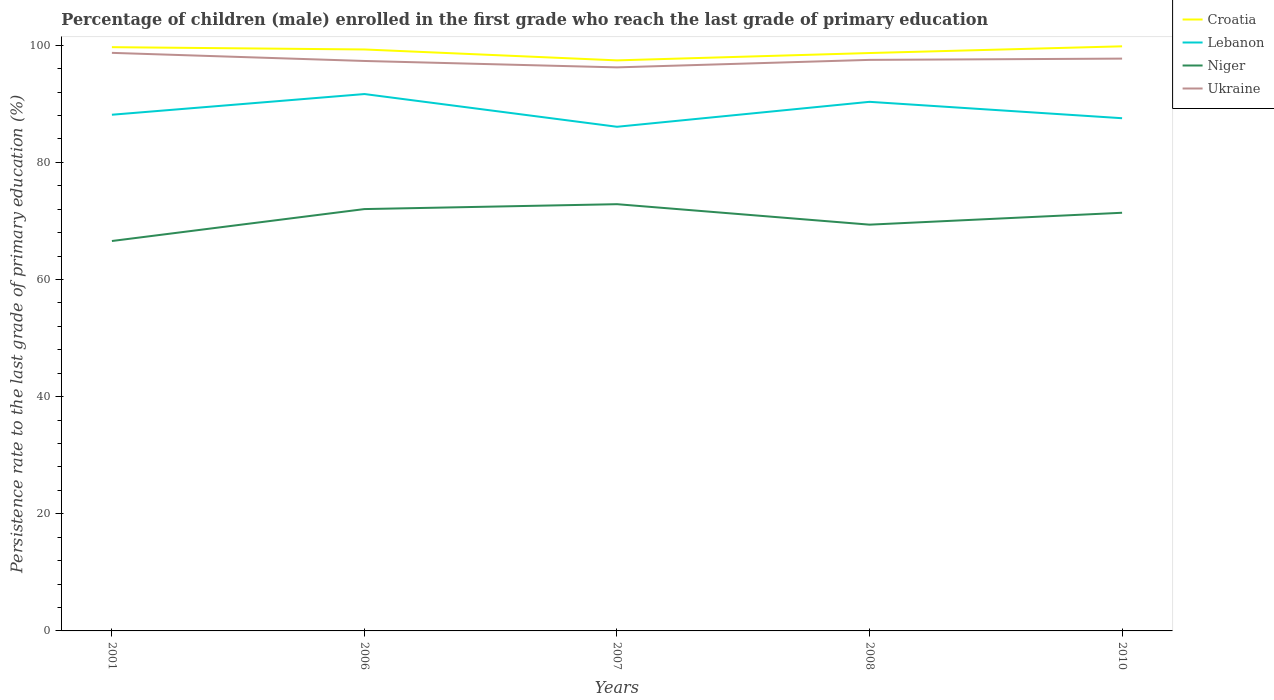How many different coloured lines are there?
Keep it short and to the point. 4. Does the line corresponding to Lebanon intersect with the line corresponding to Niger?
Ensure brevity in your answer.  No. Is the number of lines equal to the number of legend labels?
Ensure brevity in your answer.  Yes. Across all years, what is the maximum persistence rate of children in Lebanon?
Offer a terse response. 86.07. In which year was the persistence rate of children in Ukraine maximum?
Provide a succinct answer. 2007. What is the total persistence rate of children in Niger in the graph?
Your response must be concise. -4.82. What is the difference between the highest and the second highest persistence rate of children in Niger?
Make the answer very short. 6.29. How many lines are there?
Make the answer very short. 4. Does the graph contain any zero values?
Ensure brevity in your answer.  No. Does the graph contain grids?
Your answer should be very brief. No. How many legend labels are there?
Give a very brief answer. 4. What is the title of the graph?
Give a very brief answer. Percentage of children (male) enrolled in the first grade who reach the last grade of primary education. Does "Mauritania" appear as one of the legend labels in the graph?
Keep it short and to the point. No. What is the label or title of the X-axis?
Keep it short and to the point. Years. What is the label or title of the Y-axis?
Offer a terse response. Persistence rate to the last grade of primary education (%). What is the Persistence rate to the last grade of primary education (%) in Croatia in 2001?
Offer a very short reply. 99.66. What is the Persistence rate to the last grade of primary education (%) of Lebanon in 2001?
Keep it short and to the point. 88.13. What is the Persistence rate to the last grade of primary education (%) in Niger in 2001?
Your answer should be compact. 66.57. What is the Persistence rate to the last grade of primary education (%) of Ukraine in 2001?
Your answer should be compact. 98.69. What is the Persistence rate to the last grade of primary education (%) of Croatia in 2006?
Provide a succinct answer. 99.27. What is the Persistence rate to the last grade of primary education (%) of Lebanon in 2006?
Provide a succinct answer. 91.66. What is the Persistence rate to the last grade of primary education (%) in Niger in 2006?
Your answer should be compact. 72.02. What is the Persistence rate to the last grade of primary education (%) of Ukraine in 2006?
Ensure brevity in your answer.  97.31. What is the Persistence rate to the last grade of primary education (%) in Croatia in 2007?
Ensure brevity in your answer.  97.41. What is the Persistence rate to the last grade of primary education (%) in Lebanon in 2007?
Give a very brief answer. 86.07. What is the Persistence rate to the last grade of primary education (%) of Niger in 2007?
Keep it short and to the point. 72.86. What is the Persistence rate to the last grade of primary education (%) in Ukraine in 2007?
Make the answer very short. 96.22. What is the Persistence rate to the last grade of primary education (%) in Croatia in 2008?
Your response must be concise. 98.66. What is the Persistence rate to the last grade of primary education (%) of Lebanon in 2008?
Give a very brief answer. 90.33. What is the Persistence rate to the last grade of primary education (%) of Niger in 2008?
Your response must be concise. 69.36. What is the Persistence rate to the last grade of primary education (%) of Ukraine in 2008?
Provide a short and direct response. 97.5. What is the Persistence rate to the last grade of primary education (%) in Croatia in 2010?
Your answer should be compact. 99.81. What is the Persistence rate to the last grade of primary education (%) of Lebanon in 2010?
Make the answer very short. 87.54. What is the Persistence rate to the last grade of primary education (%) in Niger in 2010?
Keep it short and to the point. 71.39. What is the Persistence rate to the last grade of primary education (%) in Ukraine in 2010?
Keep it short and to the point. 97.71. Across all years, what is the maximum Persistence rate to the last grade of primary education (%) in Croatia?
Make the answer very short. 99.81. Across all years, what is the maximum Persistence rate to the last grade of primary education (%) in Lebanon?
Ensure brevity in your answer.  91.66. Across all years, what is the maximum Persistence rate to the last grade of primary education (%) of Niger?
Ensure brevity in your answer.  72.86. Across all years, what is the maximum Persistence rate to the last grade of primary education (%) of Ukraine?
Provide a short and direct response. 98.69. Across all years, what is the minimum Persistence rate to the last grade of primary education (%) in Croatia?
Offer a very short reply. 97.41. Across all years, what is the minimum Persistence rate to the last grade of primary education (%) in Lebanon?
Your response must be concise. 86.07. Across all years, what is the minimum Persistence rate to the last grade of primary education (%) of Niger?
Your response must be concise. 66.57. Across all years, what is the minimum Persistence rate to the last grade of primary education (%) in Ukraine?
Offer a very short reply. 96.22. What is the total Persistence rate to the last grade of primary education (%) in Croatia in the graph?
Offer a terse response. 494.82. What is the total Persistence rate to the last grade of primary education (%) in Lebanon in the graph?
Offer a terse response. 443.74. What is the total Persistence rate to the last grade of primary education (%) in Niger in the graph?
Offer a terse response. 352.21. What is the total Persistence rate to the last grade of primary education (%) in Ukraine in the graph?
Give a very brief answer. 487.43. What is the difference between the Persistence rate to the last grade of primary education (%) in Croatia in 2001 and that in 2006?
Provide a short and direct response. 0.39. What is the difference between the Persistence rate to the last grade of primary education (%) of Lebanon in 2001 and that in 2006?
Give a very brief answer. -3.53. What is the difference between the Persistence rate to the last grade of primary education (%) of Niger in 2001 and that in 2006?
Your answer should be very brief. -5.45. What is the difference between the Persistence rate to the last grade of primary education (%) of Ukraine in 2001 and that in 2006?
Your answer should be very brief. 1.39. What is the difference between the Persistence rate to the last grade of primary education (%) of Croatia in 2001 and that in 2007?
Keep it short and to the point. 2.25. What is the difference between the Persistence rate to the last grade of primary education (%) of Lebanon in 2001 and that in 2007?
Give a very brief answer. 2.06. What is the difference between the Persistence rate to the last grade of primary education (%) of Niger in 2001 and that in 2007?
Give a very brief answer. -6.29. What is the difference between the Persistence rate to the last grade of primary education (%) in Ukraine in 2001 and that in 2007?
Make the answer very short. 2.48. What is the difference between the Persistence rate to the last grade of primary education (%) of Lebanon in 2001 and that in 2008?
Your answer should be very brief. -2.2. What is the difference between the Persistence rate to the last grade of primary education (%) in Niger in 2001 and that in 2008?
Make the answer very short. -2.79. What is the difference between the Persistence rate to the last grade of primary education (%) of Ukraine in 2001 and that in 2008?
Offer a terse response. 1.2. What is the difference between the Persistence rate to the last grade of primary education (%) in Croatia in 2001 and that in 2010?
Provide a succinct answer. -0.15. What is the difference between the Persistence rate to the last grade of primary education (%) in Lebanon in 2001 and that in 2010?
Make the answer very short. 0.59. What is the difference between the Persistence rate to the last grade of primary education (%) of Niger in 2001 and that in 2010?
Make the answer very short. -4.82. What is the difference between the Persistence rate to the last grade of primary education (%) in Ukraine in 2001 and that in 2010?
Offer a terse response. 0.98. What is the difference between the Persistence rate to the last grade of primary education (%) of Croatia in 2006 and that in 2007?
Ensure brevity in your answer.  1.86. What is the difference between the Persistence rate to the last grade of primary education (%) in Lebanon in 2006 and that in 2007?
Ensure brevity in your answer.  5.59. What is the difference between the Persistence rate to the last grade of primary education (%) of Niger in 2006 and that in 2007?
Your answer should be very brief. -0.84. What is the difference between the Persistence rate to the last grade of primary education (%) of Ukraine in 2006 and that in 2007?
Give a very brief answer. 1.09. What is the difference between the Persistence rate to the last grade of primary education (%) in Croatia in 2006 and that in 2008?
Ensure brevity in your answer.  0.61. What is the difference between the Persistence rate to the last grade of primary education (%) of Lebanon in 2006 and that in 2008?
Your response must be concise. 1.33. What is the difference between the Persistence rate to the last grade of primary education (%) in Niger in 2006 and that in 2008?
Give a very brief answer. 2.66. What is the difference between the Persistence rate to the last grade of primary education (%) of Ukraine in 2006 and that in 2008?
Keep it short and to the point. -0.19. What is the difference between the Persistence rate to the last grade of primary education (%) in Croatia in 2006 and that in 2010?
Ensure brevity in your answer.  -0.54. What is the difference between the Persistence rate to the last grade of primary education (%) in Lebanon in 2006 and that in 2010?
Give a very brief answer. 4.13. What is the difference between the Persistence rate to the last grade of primary education (%) of Niger in 2006 and that in 2010?
Offer a very short reply. 0.63. What is the difference between the Persistence rate to the last grade of primary education (%) of Ukraine in 2006 and that in 2010?
Give a very brief answer. -0.4. What is the difference between the Persistence rate to the last grade of primary education (%) of Croatia in 2007 and that in 2008?
Offer a very short reply. -1.25. What is the difference between the Persistence rate to the last grade of primary education (%) in Lebanon in 2007 and that in 2008?
Keep it short and to the point. -4.26. What is the difference between the Persistence rate to the last grade of primary education (%) of Niger in 2007 and that in 2008?
Offer a terse response. 3.5. What is the difference between the Persistence rate to the last grade of primary education (%) of Ukraine in 2007 and that in 2008?
Ensure brevity in your answer.  -1.28. What is the difference between the Persistence rate to the last grade of primary education (%) of Croatia in 2007 and that in 2010?
Provide a succinct answer. -2.4. What is the difference between the Persistence rate to the last grade of primary education (%) in Lebanon in 2007 and that in 2010?
Your response must be concise. -1.46. What is the difference between the Persistence rate to the last grade of primary education (%) of Niger in 2007 and that in 2010?
Make the answer very short. 1.46. What is the difference between the Persistence rate to the last grade of primary education (%) of Ukraine in 2007 and that in 2010?
Your answer should be compact. -1.5. What is the difference between the Persistence rate to the last grade of primary education (%) in Croatia in 2008 and that in 2010?
Keep it short and to the point. -1.15. What is the difference between the Persistence rate to the last grade of primary education (%) of Lebanon in 2008 and that in 2010?
Ensure brevity in your answer.  2.8. What is the difference between the Persistence rate to the last grade of primary education (%) of Niger in 2008 and that in 2010?
Provide a short and direct response. -2.03. What is the difference between the Persistence rate to the last grade of primary education (%) of Ukraine in 2008 and that in 2010?
Provide a short and direct response. -0.22. What is the difference between the Persistence rate to the last grade of primary education (%) of Croatia in 2001 and the Persistence rate to the last grade of primary education (%) of Lebanon in 2006?
Your answer should be very brief. 8. What is the difference between the Persistence rate to the last grade of primary education (%) in Croatia in 2001 and the Persistence rate to the last grade of primary education (%) in Niger in 2006?
Your response must be concise. 27.64. What is the difference between the Persistence rate to the last grade of primary education (%) in Croatia in 2001 and the Persistence rate to the last grade of primary education (%) in Ukraine in 2006?
Your answer should be compact. 2.36. What is the difference between the Persistence rate to the last grade of primary education (%) of Lebanon in 2001 and the Persistence rate to the last grade of primary education (%) of Niger in 2006?
Give a very brief answer. 16.11. What is the difference between the Persistence rate to the last grade of primary education (%) of Lebanon in 2001 and the Persistence rate to the last grade of primary education (%) of Ukraine in 2006?
Ensure brevity in your answer.  -9.18. What is the difference between the Persistence rate to the last grade of primary education (%) in Niger in 2001 and the Persistence rate to the last grade of primary education (%) in Ukraine in 2006?
Give a very brief answer. -30.74. What is the difference between the Persistence rate to the last grade of primary education (%) of Croatia in 2001 and the Persistence rate to the last grade of primary education (%) of Lebanon in 2007?
Offer a terse response. 13.59. What is the difference between the Persistence rate to the last grade of primary education (%) of Croatia in 2001 and the Persistence rate to the last grade of primary education (%) of Niger in 2007?
Offer a very short reply. 26.81. What is the difference between the Persistence rate to the last grade of primary education (%) of Croatia in 2001 and the Persistence rate to the last grade of primary education (%) of Ukraine in 2007?
Provide a short and direct response. 3.45. What is the difference between the Persistence rate to the last grade of primary education (%) in Lebanon in 2001 and the Persistence rate to the last grade of primary education (%) in Niger in 2007?
Make the answer very short. 15.27. What is the difference between the Persistence rate to the last grade of primary education (%) of Lebanon in 2001 and the Persistence rate to the last grade of primary education (%) of Ukraine in 2007?
Provide a succinct answer. -8.09. What is the difference between the Persistence rate to the last grade of primary education (%) of Niger in 2001 and the Persistence rate to the last grade of primary education (%) of Ukraine in 2007?
Ensure brevity in your answer.  -29.65. What is the difference between the Persistence rate to the last grade of primary education (%) of Croatia in 2001 and the Persistence rate to the last grade of primary education (%) of Lebanon in 2008?
Offer a terse response. 9.33. What is the difference between the Persistence rate to the last grade of primary education (%) in Croatia in 2001 and the Persistence rate to the last grade of primary education (%) in Niger in 2008?
Give a very brief answer. 30.3. What is the difference between the Persistence rate to the last grade of primary education (%) in Croatia in 2001 and the Persistence rate to the last grade of primary education (%) in Ukraine in 2008?
Provide a short and direct response. 2.17. What is the difference between the Persistence rate to the last grade of primary education (%) in Lebanon in 2001 and the Persistence rate to the last grade of primary education (%) in Niger in 2008?
Your response must be concise. 18.77. What is the difference between the Persistence rate to the last grade of primary education (%) in Lebanon in 2001 and the Persistence rate to the last grade of primary education (%) in Ukraine in 2008?
Your answer should be compact. -9.37. What is the difference between the Persistence rate to the last grade of primary education (%) of Niger in 2001 and the Persistence rate to the last grade of primary education (%) of Ukraine in 2008?
Provide a succinct answer. -30.92. What is the difference between the Persistence rate to the last grade of primary education (%) in Croatia in 2001 and the Persistence rate to the last grade of primary education (%) in Lebanon in 2010?
Keep it short and to the point. 12.13. What is the difference between the Persistence rate to the last grade of primary education (%) of Croatia in 2001 and the Persistence rate to the last grade of primary education (%) of Niger in 2010?
Your response must be concise. 28.27. What is the difference between the Persistence rate to the last grade of primary education (%) of Croatia in 2001 and the Persistence rate to the last grade of primary education (%) of Ukraine in 2010?
Offer a terse response. 1.95. What is the difference between the Persistence rate to the last grade of primary education (%) of Lebanon in 2001 and the Persistence rate to the last grade of primary education (%) of Niger in 2010?
Your answer should be very brief. 16.74. What is the difference between the Persistence rate to the last grade of primary education (%) in Lebanon in 2001 and the Persistence rate to the last grade of primary education (%) in Ukraine in 2010?
Provide a short and direct response. -9.58. What is the difference between the Persistence rate to the last grade of primary education (%) of Niger in 2001 and the Persistence rate to the last grade of primary education (%) of Ukraine in 2010?
Provide a succinct answer. -31.14. What is the difference between the Persistence rate to the last grade of primary education (%) in Croatia in 2006 and the Persistence rate to the last grade of primary education (%) in Lebanon in 2007?
Your response must be concise. 13.2. What is the difference between the Persistence rate to the last grade of primary education (%) in Croatia in 2006 and the Persistence rate to the last grade of primary education (%) in Niger in 2007?
Offer a very short reply. 26.41. What is the difference between the Persistence rate to the last grade of primary education (%) in Croatia in 2006 and the Persistence rate to the last grade of primary education (%) in Ukraine in 2007?
Keep it short and to the point. 3.06. What is the difference between the Persistence rate to the last grade of primary education (%) in Lebanon in 2006 and the Persistence rate to the last grade of primary education (%) in Niger in 2007?
Give a very brief answer. 18.8. What is the difference between the Persistence rate to the last grade of primary education (%) of Lebanon in 2006 and the Persistence rate to the last grade of primary education (%) of Ukraine in 2007?
Give a very brief answer. -4.55. What is the difference between the Persistence rate to the last grade of primary education (%) in Niger in 2006 and the Persistence rate to the last grade of primary education (%) in Ukraine in 2007?
Provide a short and direct response. -24.19. What is the difference between the Persistence rate to the last grade of primary education (%) in Croatia in 2006 and the Persistence rate to the last grade of primary education (%) in Lebanon in 2008?
Ensure brevity in your answer.  8.94. What is the difference between the Persistence rate to the last grade of primary education (%) of Croatia in 2006 and the Persistence rate to the last grade of primary education (%) of Niger in 2008?
Provide a succinct answer. 29.91. What is the difference between the Persistence rate to the last grade of primary education (%) of Croatia in 2006 and the Persistence rate to the last grade of primary education (%) of Ukraine in 2008?
Your answer should be very brief. 1.78. What is the difference between the Persistence rate to the last grade of primary education (%) of Lebanon in 2006 and the Persistence rate to the last grade of primary education (%) of Niger in 2008?
Keep it short and to the point. 22.3. What is the difference between the Persistence rate to the last grade of primary education (%) in Lebanon in 2006 and the Persistence rate to the last grade of primary education (%) in Ukraine in 2008?
Offer a very short reply. -5.83. What is the difference between the Persistence rate to the last grade of primary education (%) of Niger in 2006 and the Persistence rate to the last grade of primary education (%) of Ukraine in 2008?
Your answer should be compact. -25.47. What is the difference between the Persistence rate to the last grade of primary education (%) of Croatia in 2006 and the Persistence rate to the last grade of primary education (%) of Lebanon in 2010?
Make the answer very short. 11.74. What is the difference between the Persistence rate to the last grade of primary education (%) of Croatia in 2006 and the Persistence rate to the last grade of primary education (%) of Niger in 2010?
Offer a terse response. 27.88. What is the difference between the Persistence rate to the last grade of primary education (%) of Croatia in 2006 and the Persistence rate to the last grade of primary education (%) of Ukraine in 2010?
Your response must be concise. 1.56. What is the difference between the Persistence rate to the last grade of primary education (%) of Lebanon in 2006 and the Persistence rate to the last grade of primary education (%) of Niger in 2010?
Your response must be concise. 20.27. What is the difference between the Persistence rate to the last grade of primary education (%) in Lebanon in 2006 and the Persistence rate to the last grade of primary education (%) in Ukraine in 2010?
Provide a succinct answer. -6.05. What is the difference between the Persistence rate to the last grade of primary education (%) in Niger in 2006 and the Persistence rate to the last grade of primary education (%) in Ukraine in 2010?
Offer a very short reply. -25.69. What is the difference between the Persistence rate to the last grade of primary education (%) of Croatia in 2007 and the Persistence rate to the last grade of primary education (%) of Lebanon in 2008?
Your response must be concise. 7.08. What is the difference between the Persistence rate to the last grade of primary education (%) of Croatia in 2007 and the Persistence rate to the last grade of primary education (%) of Niger in 2008?
Your answer should be very brief. 28.05. What is the difference between the Persistence rate to the last grade of primary education (%) of Croatia in 2007 and the Persistence rate to the last grade of primary education (%) of Ukraine in 2008?
Your response must be concise. -0.09. What is the difference between the Persistence rate to the last grade of primary education (%) in Lebanon in 2007 and the Persistence rate to the last grade of primary education (%) in Niger in 2008?
Ensure brevity in your answer.  16.71. What is the difference between the Persistence rate to the last grade of primary education (%) of Lebanon in 2007 and the Persistence rate to the last grade of primary education (%) of Ukraine in 2008?
Ensure brevity in your answer.  -11.42. What is the difference between the Persistence rate to the last grade of primary education (%) in Niger in 2007 and the Persistence rate to the last grade of primary education (%) in Ukraine in 2008?
Offer a terse response. -24.64. What is the difference between the Persistence rate to the last grade of primary education (%) in Croatia in 2007 and the Persistence rate to the last grade of primary education (%) in Lebanon in 2010?
Keep it short and to the point. 9.88. What is the difference between the Persistence rate to the last grade of primary education (%) in Croatia in 2007 and the Persistence rate to the last grade of primary education (%) in Niger in 2010?
Your answer should be compact. 26.02. What is the difference between the Persistence rate to the last grade of primary education (%) in Croatia in 2007 and the Persistence rate to the last grade of primary education (%) in Ukraine in 2010?
Your response must be concise. -0.3. What is the difference between the Persistence rate to the last grade of primary education (%) in Lebanon in 2007 and the Persistence rate to the last grade of primary education (%) in Niger in 2010?
Give a very brief answer. 14.68. What is the difference between the Persistence rate to the last grade of primary education (%) in Lebanon in 2007 and the Persistence rate to the last grade of primary education (%) in Ukraine in 2010?
Provide a short and direct response. -11.64. What is the difference between the Persistence rate to the last grade of primary education (%) of Niger in 2007 and the Persistence rate to the last grade of primary education (%) of Ukraine in 2010?
Make the answer very short. -24.85. What is the difference between the Persistence rate to the last grade of primary education (%) of Croatia in 2008 and the Persistence rate to the last grade of primary education (%) of Lebanon in 2010?
Provide a succinct answer. 11.13. What is the difference between the Persistence rate to the last grade of primary education (%) of Croatia in 2008 and the Persistence rate to the last grade of primary education (%) of Niger in 2010?
Your answer should be very brief. 27.27. What is the difference between the Persistence rate to the last grade of primary education (%) of Croatia in 2008 and the Persistence rate to the last grade of primary education (%) of Ukraine in 2010?
Your answer should be very brief. 0.95. What is the difference between the Persistence rate to the last grade of primary education (%) of Lebanon in 2008 and the Persistence rate to the last grade of primary education (%) of Niger in 2010?
Offer a terse response. 18.94. What is the difference between the Persistence rate to the last grade of primary education (%) in Lebanon in 2008 and the Persistence rate to the last grade of primary education (%) in Ukraine in 2010?
Your answer should be very brief. -7.38. What is the difference between the Persistence rate to the last grade of primary education (%) of Niger in 2008 and the Persistence rate to the last grade of primary education (%) of Ukraine in 2010?
Ensure brevity in your answer.  -28.35. What is the average Persistence rate to the last grade of primary education (%) in Croatia per year?
Ensure brevity in your answer.  98.96. What is the average Persistence rate to the last grade of primary education (%) in Lebanon per year?
Provide a succinct answer. 88.75. What is the average Persistence rate to the last grade of primary education (%) in Niger per year?
Keep it short and to the point. 70.44. What is the average Persistence rate to the last grade of primary education (%) in Ukraine per year?
Provide a succinct answer. 97.49. In the year 2001, what is the difference between the Persistence rate to the last grade of primary education (%) of Croatia and Persistence rate to the last grade of primary education (%) of Lebanon?
Your response must be concise. 11.53. In the year 2001, what is the difference between the Persistence rate to the last grade of primary education (%) of Croatia and Persistence rate to the last grade of primary education (%) of Niger?
Your answer should be very brief. 33.09. In the year 2001, what is the difference between the Persistence rate to the last grade of primary education (%) of Croatia and Persistence rate to the last grade of primary education (%) of Ukraine?
Make the answer very short. 0.97. In the year 2001, what is the difference between the Persistence rate to the last grade of primary education (%) of Lebanon and Persistence rate to the last grade of primary education (%) of Niger?
Provide a short and direct response. 21.56. In the year 2001, what is the difference between the Persistence rate to the last grade of primary education (%) in Lebanon and Persistence rate to the last grade of primary education (%) in Ukraine?
Provide a short and direct response. -10.56. In the year 2001, what is the difference between the Persistence rate to the last grade of primary education (%) in Niger and Persistence rate to the last grade of primary education (%) in Ukraine?
Your answer should be compact. -32.12. In the year 2006, what is the difference between the Persistence rate to the last grade of primary education (%) of Croatia and Persistence rate to the last grade of primary education (%) of Lebanon?
Ensure brevity in your answer.  7.61. In the year 2006, what is the difference between the Persistence rate to the last grade of primary education (%) of Croatia and Persistence rate to the last grade of primary education (%) of Niger?
Provide a short and direct response. 27.25. In the year 2006, what is the difference between the Persistence rate to the last grade of primary education (%) of Croatia and Persistence rate to the last grade of primary education (%) of Ukraine?
Your answer should be very brief. 1.96. In the year 2006, what is the difference between the Persistence rate to the last grade of primary education (%) in Lebanon and Persistence rate to the last grade of primary education (%) in Niger?
Offer a terse response. 19.64. In the year 2006, what is the difference between the Persistence rate to the last grade of primary education (%) in Lebanon and Persistence rate to the last grade of primary education (%) in Ukraine?
Your answer should be very brief. -5.65. In the year 2006, what is the difference between the Persistence rate to the last grade of primary education (%) of Niger and Persistence rate to the last grade of primary education (%) of Ukraine?
Your answer should be compact. -25.29. In the year 2007, what is the difference between the Persistence rate to the last grade of primary education (%) in Croatia and Persistence rate to the last grade of primary education (%) in Lebanon?
Give a very brief answer. 11.34. In the year 2007, what is the difference between the Persistence rate to the last grade of primary education (%) of Croatia and Persistence rate to the last grade of primary education (%) of Niger?
Keep it short and to the point. 24.55. In the year 2007, what is the difference between the Persistence rate to the last grade of primary education (%) in Croatia and Persistence rate to the last grade of primary education (%) in Ukraine?
Give a very brief answer. 1.19. In the year 2007, what is the difference between the Persistence rate to the last grade of primary education (%) in Lebanon and Persistence rate to the last grade of primary education (%) in Niger?
Your answer should be very brief. 13.22. In the year 2007, what is the difference between the Persistence rate to the last grade of primary education (%) of Lebanon and Persistence rate to the last grade of primary education (%) of Ukraine?
Make the answer very short. -10.14. In the year 2007, what is the difference between the Persistence rate to the last grade of primary education (%) of Niger and Persistence rate to the last grade of primary education (%) of Ukraine?
Ensure brevity in your answer.  -23.36. In the year 2008, what is the difference between the Persistence rate to the last grade of primary education (%) of Croatia and Persistence rate to the last grade of primary education (%) of Lebanon?
Make the answer very short. 8.33. In the year 2008, what is the difference between the Persistence rate to the last grade of primary education (%) of Croatia and Persistence rate to the last grade of primary education (%) of Niger?
Ensure brevity in your answer.  29.3. In the year 2008, what is the difference between the Persistence rate to the last grade of primary education (%) of Croatia and Persistence rate to the last grade of primary education (%) of Ukraine?
Ensure brevity in your answer.  1.17. In the year 2008, what is the difference between the Persistence rate to the last grade of primary education (%) in Lebanon and Persistence rate to the last grade of primary education (%) in Niger?
Ensure brevity in your answer.  20.97. In the year 2008, what is the difference between the Persistence rate to the last grade of primary education (%) of Lebanon and Persistence rate to the last grade of primary education (%) of Ukraine?
Provide a succinct answer. -7.16. In the year 2008, what is the difference between the Persistence rate to the last grade of primary education (%) in Niger and Persistence rate to the last grade of primary education (%) in Ukraine?
Your response must be concise. -28.13. In the year 2010, what is the difference between the Persistence rate to the last grade of primary education (%) in Croatia and Persistence rate to the last grade of primary education (%) in Lebanon?
Offer a very short reply. 12.28. In the year 2010, what is the difference between the Persistence rate to the last grade of primary education (%) of Croatia and Persistence rate to the last grade of primary education (%) of Niger?
Provide a short and direct response. 28.42. In the year 2010, what is the difference between the Persistence rate to the last grade of primary education (%) of Croatia and Persistence rate to the last grade of primary education (%) of Ukraine?
Provide a succinct answer. 2.1. In the year 2010, what is the difference between the Persistence rate to the last grade of primary education (%) in Lebanon and Persistence rate to the last grade of primary education (%) in Niger?
Offer a terse response. 16.14. In the year 2010, what is the difference between the Persistence rate to the last grade of primary education (%) in Lebanon and Persistence rate to the last grade of primary education (%) in Ukraine?
Provide a succinct answer. -10.18. In the year 2010, what is the difference between the Persistence rate to the last grade of primary education (%) of Niger and Persistence rate to the last grade of primary education (%) of Ukraine?
Ensure brevity in your answer.  -26.32. What is the ratio of the Persistence rate to the last grade of primary education (%) in Croatia in 2001 to that in 2006?
Your answer should be compact. 1. What is the ratio of the Persistence rate to the last grade of primary education (%) of Lebanon in 2001 to that in 2006?
Your answer should be very brief. 0.96. What is the ratio of the Persistence rate to the last grade of primary education (%) of Niger in 2001 to that in 2006?
Your response must be concise. 0.92. What is the ratio of the Persistence rate to the last grade of primary education (%) of Ukraine in 2001 to that in 2006?
Your answer should be very brief. 1.01. What is the ratio of the Persistence rate to the last grade of primary education (%) in Croatia in 2001 to that in 2007?
Make the answer very short. 1.02. What is the ratio of the Persistence rate to the last grade of primary education (%) in Lebanon in 2001 to that in 2007?
Your answer should be very brief. 1.02. What is the ratio of the Persistence rate to the last grade of primary education (%) of Niger in 2001 to that in 2007?
Give a very brief answer. 0.91. What is the ratio of the Persistence rate to the last grade of primary education (%) of Ukraine in 2001 to that in 2007?
Make the answer very short. 1.03. What is the ratio of the Persistence rate to the last grade of primary education (%) in Lebanon in 2001 to that in 2008?
Your answer should be compact. 0.98. What is the ratio of the Persistence rate to the last grade of primary education (%) of Niger in 2001 to that in 2008?
Your response must be concise. 0.96. What is the ratio of the Persistence rate to the last grade of primary education (%) in Ukraine in 2001 to that in 2008?
Keep it short and to the point. 1.01. What is the ratio of the Persistence rate to the last grade of primary education (%) of Lebanon in 2001 to that in 2010?
Your response must be concise. 1.01. What is the ratio of the Persistence rate to the last grade of primary education (%) of Niger in 2001 to that in 2010?
Offer a very short reply. 0.93. What is the ratio of the Persistence rate to the last grade of primary education (%) of Ukraine in 2001 to that in 2010?
Ensure brevity in your answer.  1.01. What is the ratio of the Persistence rate to the last grade of primary education (%) in Croatia in 2006 to that in 2007?
Offer a terse response. 1.02. What is the ratio of the Persistence rate to the last grade of primary education (%) of Lebanon in 2006 to that in 2007?
Your response must be concise. 1.06. What is the ratio of the Persistence rate to the last grade of primary education (%) of Niger in 2006 to that in 2007?
Provide a succinct answer. 0.99. What is the ratio of the Persistence rate to the last grade of primary education (%) of Ukraine in 2006 to that in 2007?
Keep it short and to the point. 1.01. What is the ratio of the Persistence rate to the last grade of primary education (%) in Lebanon in 2006 to that in 2008?
Ensure brevity in your answer.  1.01. What is the ratio of the Persistence rate to the last grade of primary education (%) of Niger in 2006 to that in 2008?
Your answer should be compact. 1.04. What is the ratio of the Persistence rate to the last grade of primary education (%) in Ukraine in 2006 to that in 2008?
Keep it short and to the point. 1. What is the ratio of the Persistence rate to the last grade of primary education (%) of Lebanon in 2006 to that in 2010?
Offer a very short reply. 1.05. What is the ratio of the Persistence rate to the last grade of primary education (%) of Niger in 2006 to that in 2010?
Offer a terse response. 1.01. What is the ratio of the Persistence rate to the last grade of primary education (%) of Croatia in 2007 to that in 2008?
Your response must be concise. 0.99. What is the ratio of the Persistence rate to the last grade of primary education (%) in Lebanon in 2007 to that in 2008?
Your answer should be compact. 0.95. What is the ratio of the Persistence rate to the last grade of primary education (%) in Niger in 2007 to that in 2008?
Offer a very short reply. 1.05. What is the ratio of the Persistence rate to the last grade of primary education (%) in Ukraine in 2007 to that in 2008?
Ensure brevity in your answer.  0.99. What is the ratio of the Persistence rate to the last grade of primary education (%) in Croatia in 2007 to that in 2010?
Provide a short and direct response. 0.98. What is the ratio of the Persistence rate to the last grade of primary education (%) in Lebanon in 2007 to that in 2010?
Ensure brevity in your answer.  0.98. What is the ratio of the Persistence rate to the last grade of primary education (%) in Niger in 2007 to that in 2010?
Keep it short and to the point. 1.02. What is the ratio of the Persistence rate to the last grade of primary education (%) of Ukraine in 2007 to that in 2010?
Provide a short and direct response. 0.98. What is the ratio of the Persistence rate to the last grade of primary education (%) of Lebanon in 2008 to that in 2010?
Ensure brevity in your answer.  1.03. What is the ratio of the Persistence rate to the last grade of primary education (%) in Niger in 2008 to that in 2010?
Your answer should be very brief. 0.97. What is the difference between the highest and the second highest Persistence rate to the last grade of primary education (%) of Croatia?
Offer a very short reply. 0.15. What is the difference between the highest and the second highest Persistence rate to the last grade of primary education (%) of Lebanon?
Give a very brief answer. 1.33. What is the difference between the highest and the second highest Persistence rate to the last grade of primary education (%) in Niger?
Provide a succinct answer. 0.84. What is the difference between the highest and the second highest Persistence rate to the last grade of primary education (%) of Ukraine?
Your answer should be compact. 0.98. What is the difference between the highest and the lowest Persistence rate to the last grade of primary education (%) in Croatia?
Your response must be concise. 2.4. What is the difference between the highest and the lowest Persistence rate to the last grade of primary education (%) of Lebanon?
Offer a very short reply. 5.59. What is the difference between the highest and the lowest Persistence rate to the last grade of primary education (%) of Niger?
Offer a very short reply. 6.29. What is the difference between the highest and the lowest Persistence rate to the last grade of primary education (%) of Ukraine?
Your response must be concise. 2.48. 